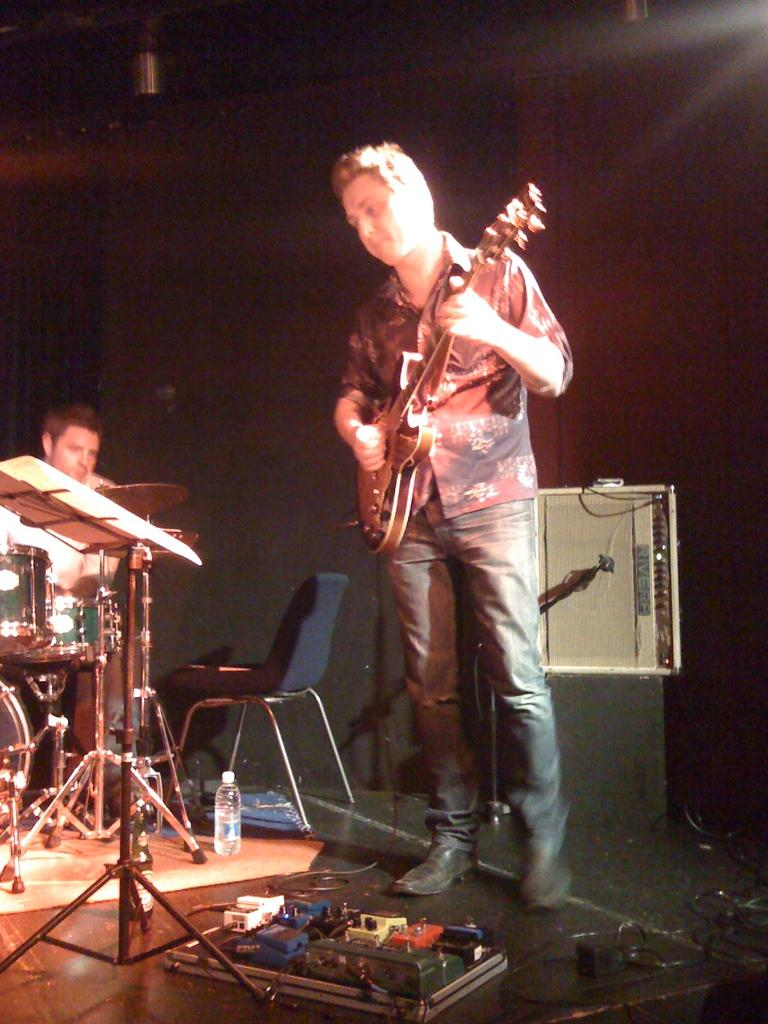What is the main activity taking place in the image? There is a man playing a guitar and another man playing a drum in the image. What type of instruments are being played in the image? A guitar and a drum are being played in the image. Where does the scene appear to be taking place? The scene appears to be on a stage. Can you see any visible veins on the guitar player's hand in the image? There is no mention of visible veins on the guitar player's hand in the image, and it is not possible to determine this information from the provided facts. 